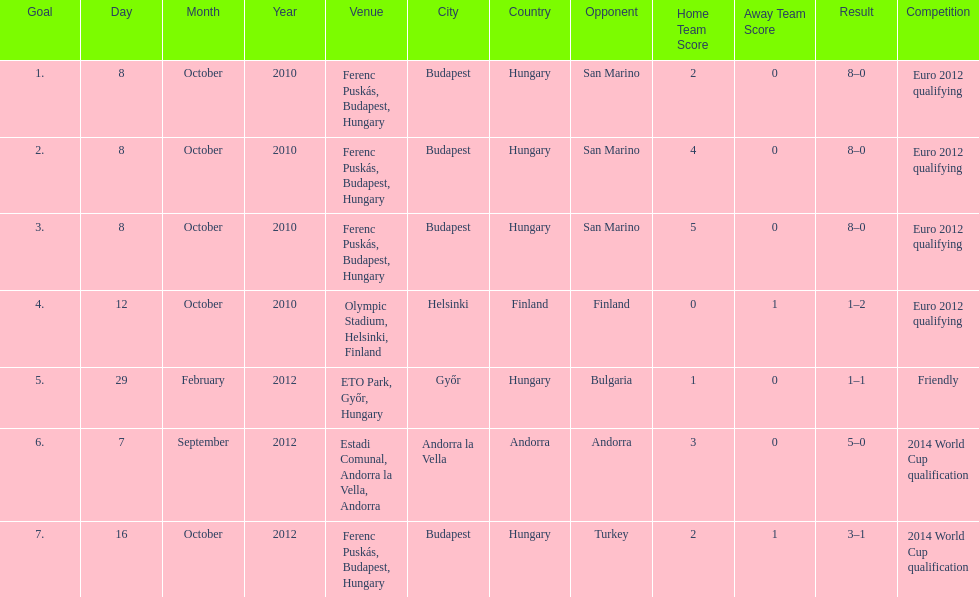How many consecutive games were goals were against san marino? 3. Can you parse all the data within this table? {'header': ['Goal', 'Day', 'Month', 'Year', 'Venue', 'City', 'Country', 'Opponent', 'Home Team Score', 'Away Team Score', 'Result', 'Competition'], 'rows': [['1.', '8', 'October', '2010', 'Ferenc Puskás, Budapest, Hungary', 'Budapest', 'Hungary', 'San Marino', '2', '0', '8–0', 'Euro 2012 qualifying'], ['2.', '8', 'October', '2010', 'Ferenc Puskás, Budapest, Hungary', 'Budapest', 'Hungary', 'San Marino', '4', '0', '8–0', 'Euro 2012 qualifying'], ['3.', '8', 'October', '2010', 'Ferenc Puskás, Budapest, Hungary', 'Budapest', 'Hungary', 'San Marino', '5', '0', '8–0', 'Euro 2012 qualifying'], ['4.', '12', 'October', '2010', 'Olympic Stadium, Helsinki, Finland', 'Helsinki', 'Finland', 'Finland', '0', '1', '1–2', 'Euro 2012 qualifying'], ['5.', '29', 'February', '2012', 'ETO Park, Győr, Hungary', 'Győr', 'Hungary', 'Bulgaria', '1', '0', '1–1', 'Friendly'], ['6.', '7', 'September', '2012', 'Estadi Comunal, Andorra la Vella, Andorra', 'Andorra la Vella', 'Andorra', 'Andorra', '3', '0', '5–0', '2014 World Cup qualification'], ['7.', '16', 'October', '2012', 'Ferenc Puskás, Budapest, Hungary', 'Budapest', 'Hungary', 'Turkey', '2', '1', '3–1', '2014 World Cup qualification']]} 